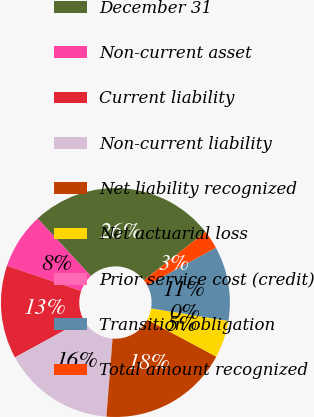Convert chart to OTSL. <chart><loc_0><loc_0><loc_500><loc_500><pie_chart><fcel>December 31<fcel>Non-current asset<fcel>Current liability<fcel>Non-current liability<fcel>Net liability recognized<fcel>Net actuarial loss<fcel>Prior service cost (credit)<fcel>Transition obligation<fcel>Total amount recognized<nl><fcel>26.31%<fcel>7.9%<fcel>13.16%<fcel>15.79%<fcel>18.42%<fcel>5.26%<fcel>0.0%<fcel>10.53%<fcel>2.63%<nl></chart> 